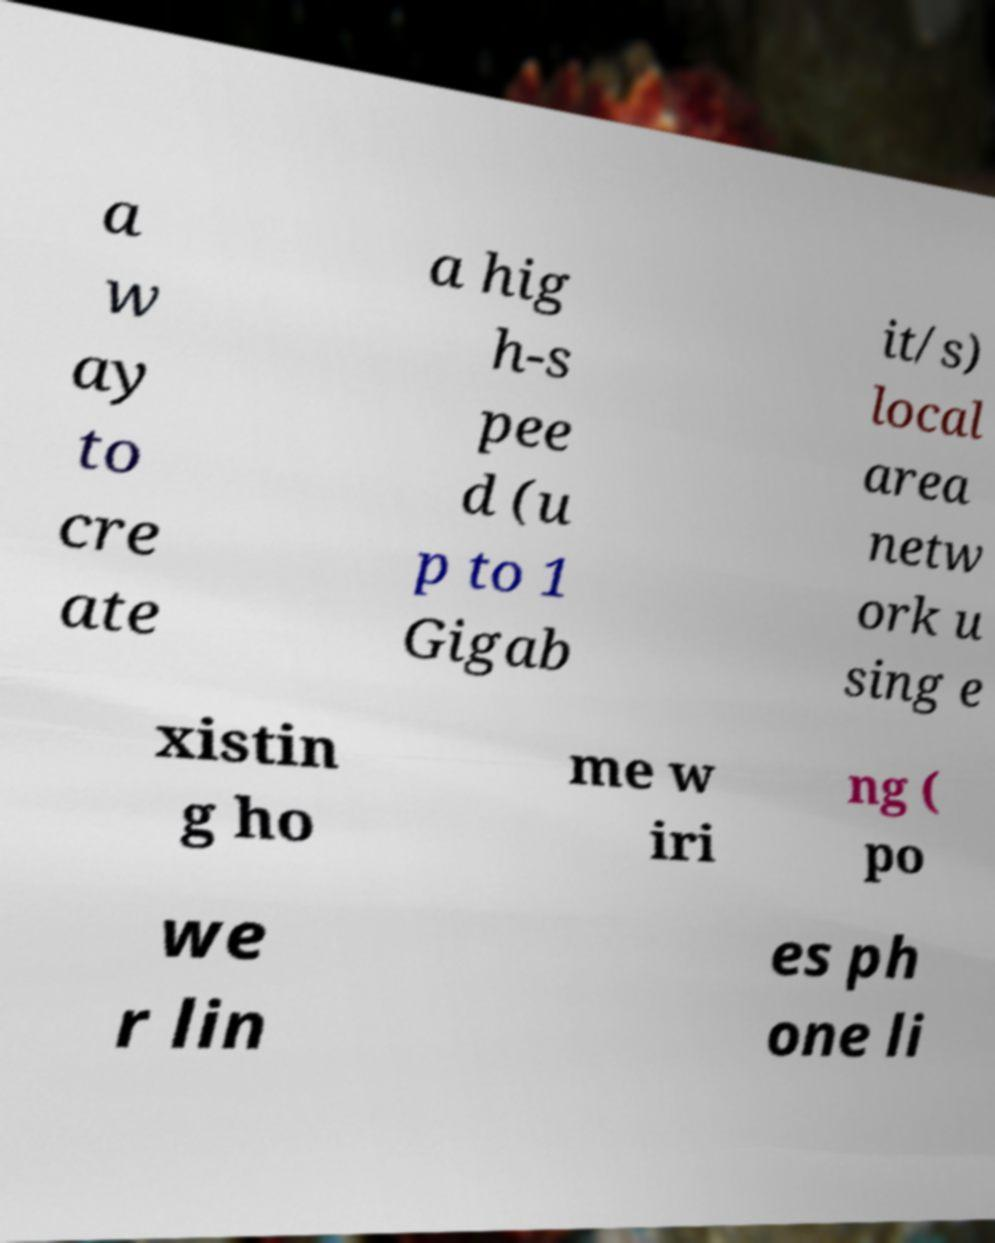Please read and relay the text visible in this image. What does it say? a w ay to cre ate a hig h-s pee d (u p to 1 Gigab it/s) local area netw ork u sing e xistin g ho me w iri ng ( po we r lin es ph one li 